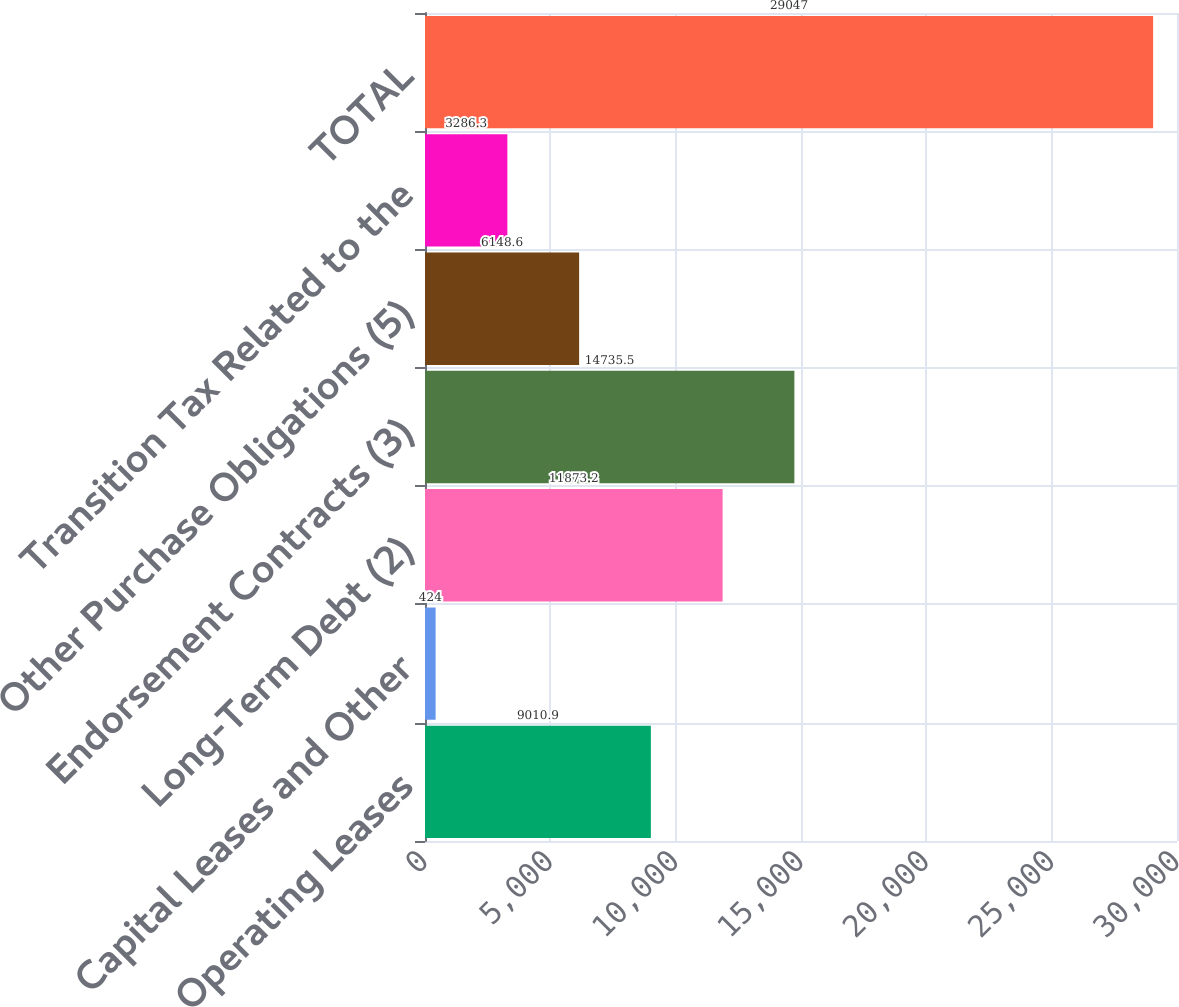<chart> <loc_0><loc_0><loc_500><loc_500><bar_chart><fcel>Operating Leases<fcel>Capital Leases and Other<fcel>Long-Term Debt (2)<fcel>Endorsement Contracts (3)<fcel>Other Purchase Obligations (5)<fcel>Transition Tax Related to the<fcel>TOTAL<nl><fcel>9010.9<fcel>424<fcel>11873.2<fcel>14735.5<fcel>6148.6<fcel>3286.3<fcel>29047<nl></chart> 